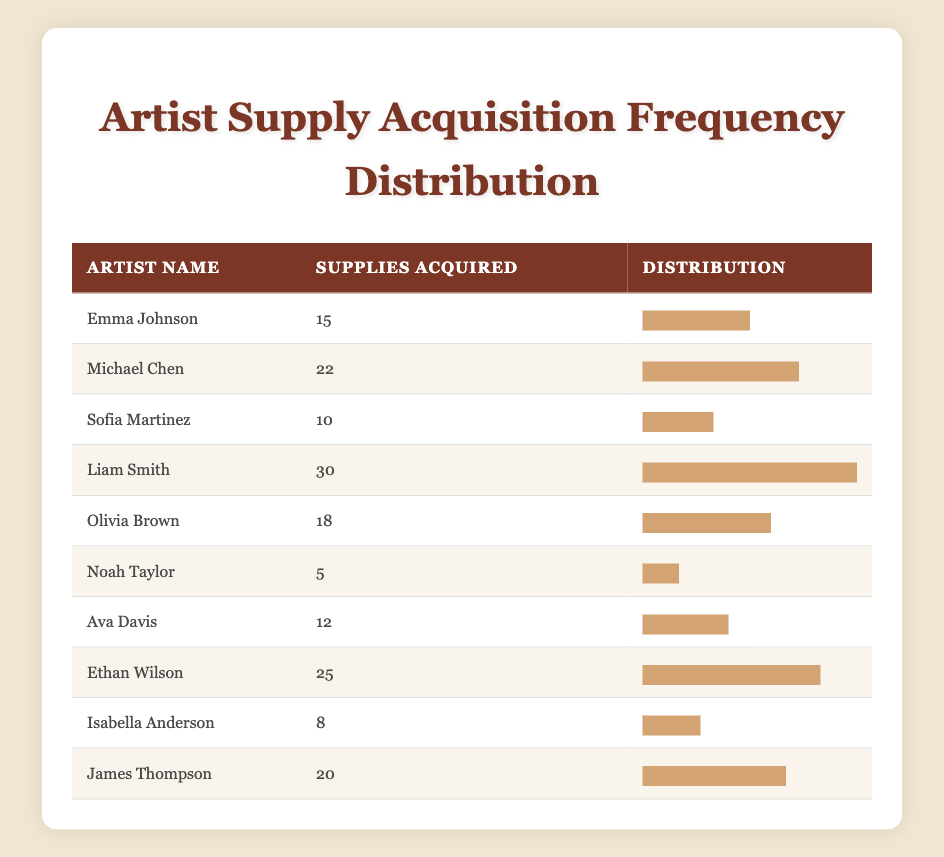What is the highest number of art supplies acquired by an artist? The highest value in the "Supplies Acquired" column is 30, which corresponds to Liam Smith.
Answer: 30 Who acquired more than 20 supplies? The artists who acquired more than 20 supplies are Michael Chen (22), Liam Smith (30), and Ethan Wilson (25).
Answer: Michael Chen, Liam Smith, Ethan Wilson What is the average number of supplies acquired by the artists listed? To find the average, sum the supplies acquired: 15 + 22 + 10 + 30 + 18 + 5 + 12 + 25 + 8 + 20 =  165. There are 10 artists, so 165 divided by 10 equals 16.5.
Answer: 16.5 How many artists acquired less than 10 supplies? Only one artist, Noah Taylor (5) and Isabella Anderson (8), acquired supplies below 10. Therefore, there are 2 artists in total.
Answer: 2 Is there an artist who acquired exactly 12 supplies? Yes, Ava Davis acquired exactly 12 supplies as indicated in the table.
Answer: Yes What is the difference between the number of supplies acquired by the artist with the least and the most? The least supplies acquired is 5 (Noah Taylor) and the most is 30 (Liam Smith). The difference is 30 - 5 = 25.
Answer: 25 Which artist acquired supplies closest to the average? The average is 16.5. The closest numbers are 15 (Emma Johnson) and 18 (Olivia Brown); both are one unit apart from the average.
Answer: Emma Johnson, Olivia Brown How many artists acquired between 10 and 20 supplies? The artists who acquired between 10 and 20 supplies are Emma Johnson (15), Olivia Brown (18), and James Thompson (20). There are 3 artists in this range.
Answer: 3 What percentage of the total number of supplies acquired is represented by supplies acquired by Liam Smith? Liam Smith acquired 30 supplies out of the total 165 (sum of all supplies). To calculate the percentage: (30/165) * 100 = 18.18%.
Answer: 18.18% 